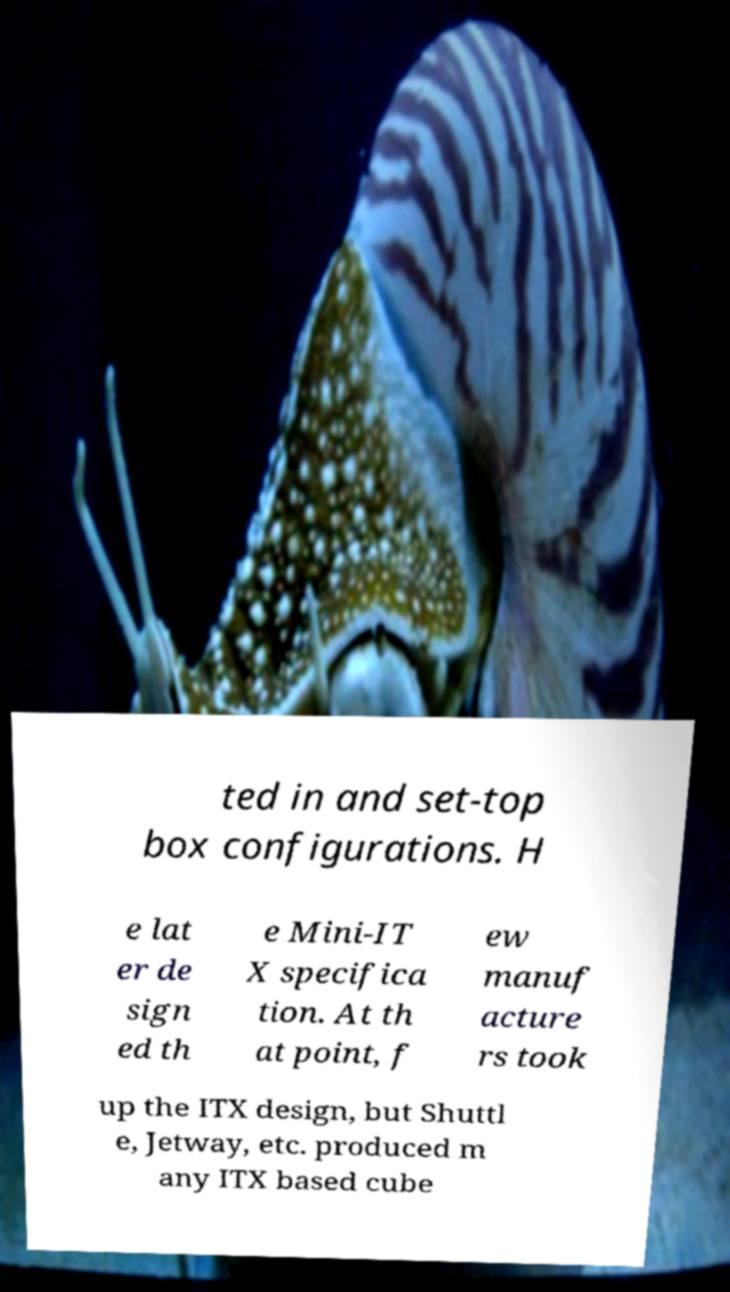Could you assist in decoding the text presented in this image and type it out clearly? ted in and set-top box configurations. H e lat er de sign ed th e Mini-IT X specifica tion. At th at point, f ew manuf acture rs took up the ITX design, but Shuttl e, Jetway, etc. produced m any ITX based cube 